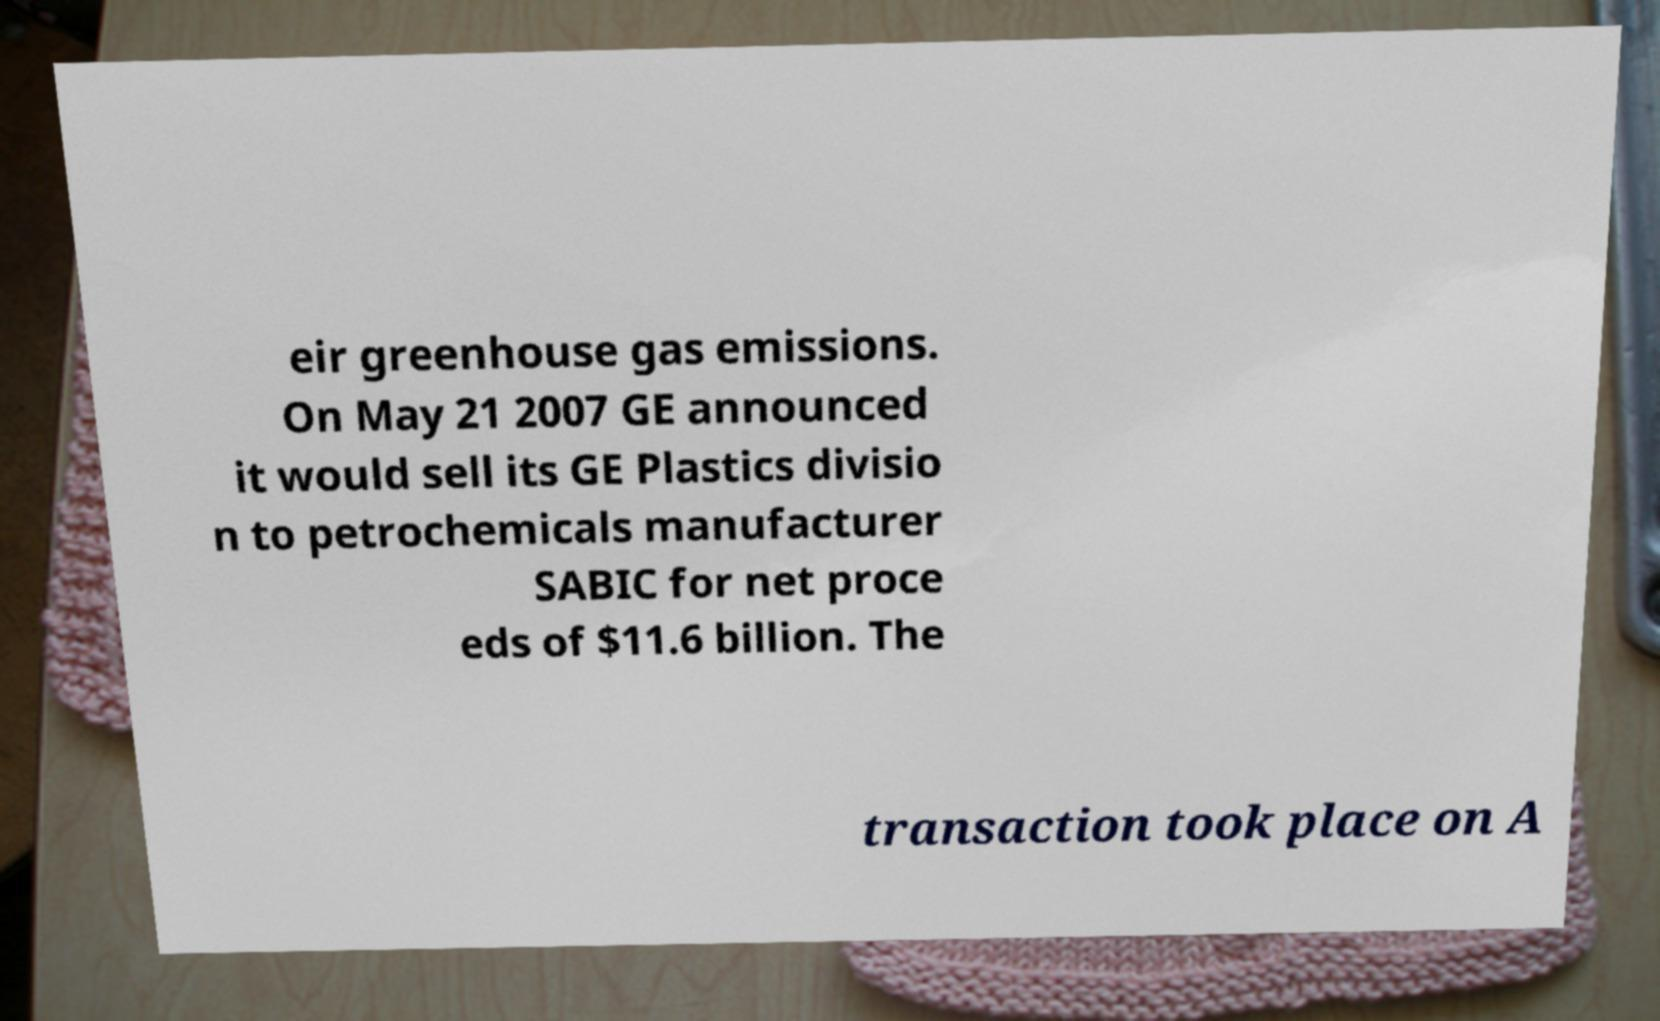I need the written content from this picture converted into text. Can you do that? eir greenhouse gas emissions. On May 21 2007 GE announced it would sell its GE Plastics divisio n to petrochemicals manufacturer SABIC for net proce eds of $11.6 billion. The transaction took place on A 